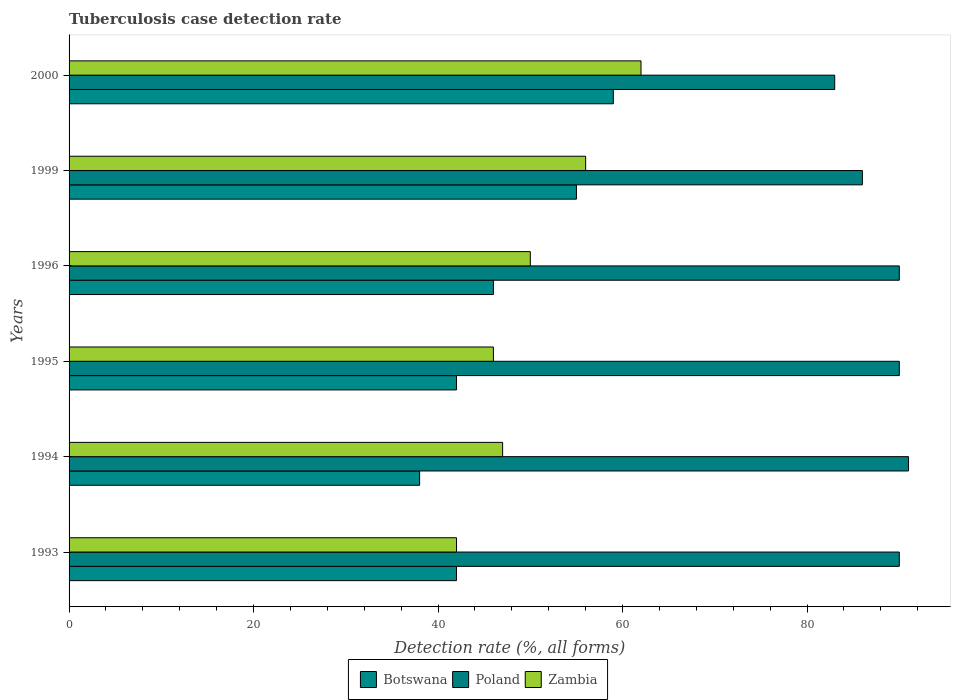How many groups of bars are there?
Your answer should be compact. 6. Are the number of bars per tick equal to the number of legend labels?
Provide a succinct answer. Yes. What is the label of the 6th group of bars from the top?
Your answer should be compact. 1993. Across all years, what is the maximum tuberculosis case detection rate in in Zambia?
Provide a short and direct response. 62. Across all years, what is the minimum tuberculosis case detection rate in in Poland?
Ensure brevity in your answer.  83. In which year was the tuberculosis case detection rate in in Poland maximum?
Offer a terse response. 1994. What is the total tuberculosis case detection rate in in Botswana in the graph?
Provide a short and direct response. 282. What is the difference between the tuberculosis case detection rate in in Zambia in 1994 and that in 1999?
Keep it short and to the point. -9. What is the difference between the tuberculosis case detection rate in in Poland in 1994 and the tuberculosis case detection rate in in Botswana in 1996?
Your answer should be very brief. 45. What is the average tuberculosis case detection rate in in Poland per year?
Offer a terse response. 88.33. In the year 1994, what is the difference between the tuberculosis case detection rate in in Poland and tuberculosis case detection rate in in Botswana?
Make the answer very short. 53. In how many years, is the tuberculosis case detection rate in in Botswana greater than 4 %?
Provide a short and direct response. 6. What is the ratio of the tuberculosis case detection rate in in Poland in 1999 to that in 2000?
Provide a succinct answer. 1.04. Is the tuberculosis case detection rate in in Poland in 1994 less than that in 1999?
Provide a short and direct response. No. What is the difference between the highest and the lowest tuberculosis case detection rate in in Poland?
Ensure brevity in your answer.  8. In how many years, is the tuberculosis case detection rate in in Botswana greater than the average tuberculosis case detection rate in in Botswana taken over all years?
Your answer should be very brief. 2. What does the 3rd bar from the top in 1996 represents?
Offer a very short reply. Botswana. What does the 1st bar from the bottom in 2000 represents?
Your answer should be compact. Botswana. Are all the bars in the graph horizontal?
Ensure brevity in your answer.  Yes. What is the difference between two consecutive major ticks on the X-axis?
Your answer should be very brief. 20. Does the graph contain any zero values?
Provide a short and direct response. No. What is the title of the graph?
Offer a terse response. Tuberculosis case detection rate. Does "Other small states" appear as one of the legend labels in the graph?
Your response must be concise. No. What is the label or title of the X-axis?
Provide a short and direct response. Detection rate (%, all forms). What is the Detection rate (%, all forms) in Zambia in 1993?
Make the answer very short. 42. What is the Detection rate (%, all forms) in Poland in 1994?
Give a very brief answer. 91. What is the Detection rate (%, all forms) in Botswana in 1995?
Offer a terse response. 42. What is the Detection rate (%, all forms) in Poland in 1996?
Your answer should be very brief. 90. What is the Detection rate (%, all forms) in Zambia in 1996?
Ensure brevity in your answer.  50. What is the Detection rate (%, all forms) in Poland in 1999?
Provide a short and direct response. 86. What is the Detection rate (%, all forms) of Botswana in 2000?
Ensure brevity in your answer.  59. What is the Detection rate (%, all forms) of Poland in 2000?
Your response must be concise. 83. Across all years, what is the maximum Detection rate (%, all forms) in Botswana?
Keep it short and to the point. 59. Across all years, what is the maximum Detection rate (%, all forms) in Poland?
Your response must be concise. 91. Across all years, what is the maximum Detection rate (%, all forms) in Zambia?
Ensure brevity in your answer.  62. Across all years, what is the minimum Detection rate (%, all forms) of Zambia?
Make the answer very short. 42. What is the total Detection rate (%, all forms) in Botswana in the graph?
Ensure brevity in your answer.  282. What is the total Detection rate (%, all forms) in Poland in the graph?
Give a very brief answer. 530. What is the total Detection rate (%, all forms) of Zambia in the graph?
Make the answer very short. 303. What is the difference between the Detection rate (%, all forms) in Poland in 1993 and that in 1994?
Offer a very short reply. -1. What is the difference between the Detection rate (%, all forms) of Poland in 1993 and that in 1995?
Ensure brevity in your answer.  0. What is the difference between the Detection rate (%, all forms) of Zambia in 1993 and that in 1999?
Keep it short and to the point. -14. What is the difference between the Detection rate (%, all forms) in Botswana in 1993 and that in 2000?
Ensure brevity in your answer.  -17. What is the difference between the Detection rate (%, all forms) of Poland in 1993 and that in 2000?
Keep it short and to the point. 7. What is the difference between the Detection rate (%, all forms) of Zambia in 1993 and that in 2000?
Ensure brevity in your answer.  -20. What is the difference between the Detection rate (%, all forms) in Botswana in 1994 and that in 1995?
Keep it short and to the point. -4. What is the difference between the Detection rate (%, all forms) in Poland in 1994 and that in 1995?
Ensure brevity in your answer.  1. What is the difference between the Detection rate (%, all forms) of Botswana in 1994 and that in 1996?
Ensure brevity in your answer.  -8. What is the difference between the Detection rate (%, all forms) in Botswana in 1994 and that in 1999?
Your answer should be compact. -17. What is the difference between the Detection rate (%, all forms) of Zambia in 1994 and that in 1999?
Make the answer very short. -9. What is the difference between the Detection rate (%, all forms) of Poland in 1994 and that in 2000?
Give a very brief answer. 8. What is the difference between the Detection rate (%, all forms) in Zambia in 1994 and that in 2000?
Provide a succinct answer. -15. What is the difference between the Detection rate (%, all forms) of Poland in 1995 and that in 1996?
Make the answer very short. 0. What is the difference between the Detection rate (%, all forms) in Zambia in 1995 and that in 1999?
Give a very brief answer. -10. What is the difference between the Detection rate (%, all forms) in Zambia in 1995 and that in 2000?
Ensure brevity in your answer.  -16. What is the difference between the Detection rate (%, all forms) in Zambia in 1996 and that in 1999?
Your answer should be very brief. -6. What is the difference between the Detection rate (%, all forms) of Zambia in 1996 and that in 2000?
Provide a succinct answer. -12. What is the difference between the Detection rate (%, all forms) in Botswana in 1999 and that in 2000?
Keep it short and to the point. -4. What is the difference between the Detection rate (%, all forms) in Botswana in 1993 and the Detection rate (%, all forms) in Poland in 1994?
Provide a succinct answer. -49. What is the difference between the Detection rate (%, all forms) in Botswana in 1993 and the Detection rate (%, all forms) in Zambia in 1994?
Your response must be concise. -5. What is the difference between the Detection rate (%, all forms) in Botswana in 1993 and the Detection rate (%, all forms) in Poland in 1995?
Offer a very short reply. -48. What is the difference between the Detection rate (%, all forms) in Botswana in 1993 and the Detection rate (%, all forms) in Zambia in 1995?
Offer a very short reply. -4. What is the difference between the Detection rate (%, all forms) in Botswana in 1993 and the Detection rate (%, all forms) in Poland in 1996?
Make the answer very short. -48. What is the difference between the Detection rate (%, all forms) in Botswana in 1993 and the Detection rate (%, all forms) in Poland in 1999?
Your answer should be very brief. -44. What is the difference between the Detection rate (%, all forms) of Botswana in 1993 and the Detection rate (%, all forms) of Zambia in 1999?
Provide a short and direct response. -14. What is the difference between the Detection rate (%, all forms) of Botswana in 1993 and the Detection rate (%, all forms) of Poland in 2000?
Ensure brevity in your answer.  -41. What is the difference between the Detection rate (%, all forms) in Botswana in 1994 and the Detection rate (%, all forms) in Poland in 1995?
Offer a terse response. -52. What is the difference between the Detection rate (%, all forms) of Poland in 1994 and the Detection rate (%, all forms) of Zambia in 1995?
Offer a very short reply. 45. What is the difference between the Detection rate (%, all forms) in Botswana in 1994 and the Detection rate (%, all forms) in Poland in 1996?
Offer a terse response. -52. What is the difference between the Detection rate (%, all forms) in Poland in 1994 and the Detection rate (%, all forms) in Zambia in 1996?
Provide a short and direct response. 41. What is the difference between the Detection rate (%, all forms) in Botswana in 1994 and the Detection rate (%, all forms) in Poland in 1999?
Provide a short and direct response. -48. What is the difference between the Detection rate (%, all forms) of Poland in 1994 and the Detection rate (%, all forms) of Zambia in 1999?
Offer a very short reply. 35. What is the difference between the Detection rate (%, all forms) in Botswana in 1994 and the Detection rate (%, all forms) in Poland in 2000?
Make the answer very short. -45. What is the difference between the Detection rate (%, all forms) in Poland in 1994 and the Detection rate (%, all forms) in Zambia in 2000?
Your response must be concise. 29. What is the difference between the Detection rate (%, all forms) of Botswana in 1995 and the Detection rate (%, all forms) of Poland in 1996?
Give a very brief answer. -48. What is the difference between the Detection rate (%, all forms) in Poland in 1995 and the Detection rate (%, all forms) in Zambia in 1996?
Give a very brief answer. 40. What is the difference between the Detection rate (%, all forms) of Botswana in 1995 and the Detection rate (%, all forms) of Poland in 1999?
Ensure brevity in your answer.  -44. What is the difference between the Detection rate (%, all forms) of Botswana in 1995 and the Detection rate (%, all forms) of Zambia in 1999?
Provide a short and direct response. -14. What is the difference between the Detection rate (%, all forms) in Poland in 1995 and the Detection rate (%, all forms) in Zambia in 1999?
Give a very brief answer. 34. What is the difference between the Detection rate (%, all forms) in Botswana in 1995 and the Detection rate (%, all forms) in Poland in 2000?
Provide a succinct answer. -41. What is the difference between the Detection rate (%, all forms) in Poland in 1995 and the Detection rate (%, all forms) in Zambia in 2000?
Offer a very short reply. 28. What is the difference between the Detection rate (%, all forms) of Botswana in 1996 and the Detection rate (%, all forms) of Zambia in 1999?
Offer a very short reply. -10. What is the difference between the Detection rate (%, all forms) in Botswana in 1996 and the Detection rate (%, all forms) in Poland in 2000?
Ensure brevity in your answer.  -37. What is the difference between the Detection rate (%, all forms) in Botswana in 1996 and the Detection rate (%, all forms) in Zambia in 2000?
Offer a terse response. -16. What is the difference between the Detection rate (%, all forms) in Poland in 1996 and the Detection rate (%, all forms) in Zambia in 2000?
Your response must be concise. 28. What is the difference between the Detection rate (%, all forms) of Botswana in 1999 and the Detection rate (%, all forms) of Zambia in 2000?
Offer a terse response. -7. What is the average Detection rate (%, all forms) of Botswana per year?
Give a very brief answer. 47. What is the average Detection rate (%, all forms) of Poland per year?
Offer a terse response. 88.33. What is the average Detection rate (%, all forms) of Zambia per year?
Your response must be concise. 50.5. In the year 1993, what is the difference between the Detection rate (%, all forms) of Botswana and Detection rate (%, all forms) of Poland?
Provide a succinct answer. -48. In the year 1993, what is the difference between the Detection rate (%, all forms) of Botswana and Detection rate (%, all forms) of Zambia?
Your response must be concise. 0. In the year 1993, what is the difference between the Detection rate (%, all forms) in Poland and Detection rate (%, all forms) in Zambia?
Keep it short and to the point. 48. In the year 1994, what is the difference between the Detection rate (%, all forms) of Botswana and Detection rate (%, all forms) of Poland?
Give a very brief answer. -53. In the year 1994, what is the difference between the Detection rate (%, all forms) in Botswana and Detection rate (%, all forms) in Zambia?
Your answer should be compact. -9. In the year 1994, what is the difference between the Detection rate (%, all forms) in Poland and Detection rate (%, all forms) in Zambia?
Offer a terse response. 44. In the year 1995, what is the difference between the Detection rate (%, all forms) in Botswana and Detection rate (%, all forms) in Poland?
Offer a terse response. -48. In the year 1995, what is the difference between the Detection rate (%, all forms) in Botswana and Detection rate (%, all forms) in Zambia?
Provide a short and direct response. -4. In the year 1995, what is the difference between the Detection rate (%, all forms) in Poland and Detection rate (%, all forms) in Zambia?
Ensure brevity in your answer.  44. In the year 1996, what is the difference between the Detection rate (%, all forms) of Botswana and Detection rate (%, all forms) of Poland?
Provide a succinct answer. -44. In the year 1999, what is the difference between the Detection rate (%, all forms) of Botswana and Detection rate (%, all forms) of Poland?
Provide a succinct answer. -31. In the year 2000, what is the difference between the Detection rate (%, all forms) in Botswana and Detection rate (%, all forms) in Zambia?
Keep it short and to the point. -3. What is the ratio of the Detection rate (%, all forms) in Botswana in 1993 to that in 1994?
Offer a very short reply. 1.11. What is the ratio of the Detection rate (%, all forms) in Poland in 1993 to that in 1994?
Make the answer very short. 0.99. What is the ratio of the Detection rate (%, all forms) of Zambia in 1993 to that in 1994?
Ensure brevity in your answer.  0.89. What is the ratio of the Detection rate (%, all forms) in Botswana in 1993 to that in 1995?
Your answer should be very brief. 1. What is the ratio of the Detection rate (%, all forms) in Poland in 1993 to that in 1995?
Your response must be concise. 1. What is the ratio of the Detection rate (%, all forms) in Zambia in 1993 to that in 1995?
Keep it short and to the point. 0.91. What is the ratio of the Detection rate (%, all forms) of Poland in 1993 to that in 1996?
Give a very brief answer. 1. What is the ratio of the Detection rate (%, all forms) in Zambia in 1993 to that in 1996?
Your response must be concise. 0.84. What is the ratio of the Detection rate (%, all forms) in Botswana in 1993 to that in 1999?
Your answer should be very brief. 0.76. What is the ratio of the Detection rate (%, all forms) of Poland in 1993 to that in 1999?
Offer a very short reply. 1.05. What is the ratio of the Detection rate (%, all forms) of Zambia in 1993 to that in 1999?
Keep it short and to the point. 0.75. What is the ratio of the Detection rate (%, all forms) of Botswana in 1993 to that in 2000?
Keep it short and to the point. 0.71. What is the ratio of the Detection rate (%, all forms) in Poland in 1993 to that in 2000?
Offer a very short reply. 1.08. What is the ratio of the Detection rate (%, all forms) in Zambia in 1993 to that in 2000?
Provide a succinct answer. 0.68. What is the ratio of the Detection rate (%, all forms) in Botswana in 1994 to that in 1995?
Make the answer very short. 0.9. What is the ratio of the Detection rate (%, all forms) of Poland in 1994 to that in 1995?
Ensure brevity in your answer.  1.01. What is the ratio of the Detection rate (%, all forms) of Zambia in 1994 to that in 1995?
Provide a short and direct response. 1.02. What is the ratio of the Detection rate (%, all forms) of Botswana in 1994 to that in 1996?
Offer a very short reply. 0.83. What is the ratio of the Detection rate (%, all forms) in Poland in 1994 to that in 1996?
Provide a succinct answer. 1.01. What is the ratio of the Detection rate (%, all forms) of Botswana in 1994 to that in 1999?
Give a very brief answer. 0.69. What is the ratio of the Detection rate (%, all forms) in Poland in 1994 to that in 1999?
Give a very brief answer. 1.06. What is the ratio of the Detection rate (%, all forms) of Zambia in 1994 to that in 1999?
Offer a very short reply. 0.84. What is the ratio of the Detection rate (%, all forms) in Botswana in 1994 to that in 2000?
Ensure brevity in your answer.  0.64. What is the ratio of the Detection rate (%, all forms) in Poland in 1994 to that in 2000?
Your response must be concise. 1.1. What is the ratio of the Detection rate (%, all forms) of Zambia in 1994 to that in 2000?
Keep it short and to the point. 0.76. What is the ratio of the Detection rate (%, all forms) in Botswana in 1995 to that in 1999?
Make the answer very short. 0.76. What is the ratio of the Detection rate (%, all forms) of Poland in 1995 to that in 1999?
Offer a terse response. 1.05. What is the ratio of the Detection rate (%, all forms) in Zambia in 1995 to that in 1999?
Provide a short and direct response. 0.82. What is the ratio of the Detection rate (%, all forms) in Botswana in 1995 to that in 2000?
Ensure brevity in your answer.  0.71. What is the ratio of the Detection rate (%, all forms) of Poland in 1995 to that in 2000?
Keep it short and to the point. 1.08. What is the ratio of the Detection rate (%, all forms) of Zambia in 1995 to that in 2000?
Provide a short and direct response. 0.74. What is the ratio of the Detection rate (%, all forms) in Botswana in 1996 to that in 1999?
Make the answer very short. 0.84. What is the ratio of the Detection rate (%, all forms) in Poland in 1996 to that in 1999?
Provide a short and direct response. 1.05. What is the ratio of the Detection rate (%, all forms) of Zambia in 1996 to that in 1999?
Keep it short and to the point. 0.89. What is the ratio of the Detection rate (%, all forms) of Botswana in 1996 to that in 2000?
Your answer should be very brief. 0.78. What is the ratio of the Detection rate (%, all forms) in Poland in 1996 to that in 2000?
Your answer should be compact. 1.08. What is the ratio of the Detection rate (%, all forms) of Zambia in 1996 to that in 2000?
Give a very brief answer. 0.81. What is the ratio of the Detection rate (%, all forms) in Botswana in 1999 to that in 2000?
Offer a very short reply. 0.93. What is the ratio of the Detection rate (%, all forms) in Poland in 1999 to that in 2000?
Offer a very short reply. 1.04. What is the ratio of the Detection rate (%, all forms) in Zambia in 1999 to that in 2000?
Make the answer very short. 0.9. What is the difference between the highest and the second highest Detection rate (%, all forms) of Botswana?
Offer a very short reply. 4. What is the difference between the highest and the second highest Detection rate (%, all forms) of Poland?
Give a very brief answer. 1. What is the difference between the highest and the second highest Detection rate (%, all forms) of Zambia?
Your response must be concise. 6. What is the difference between the highest and the lowest Detection rate (%, all forms) of Zambia?
Give a very brief answer. 20. 